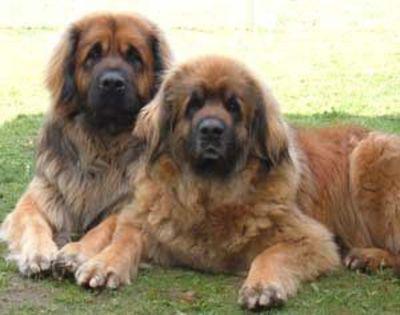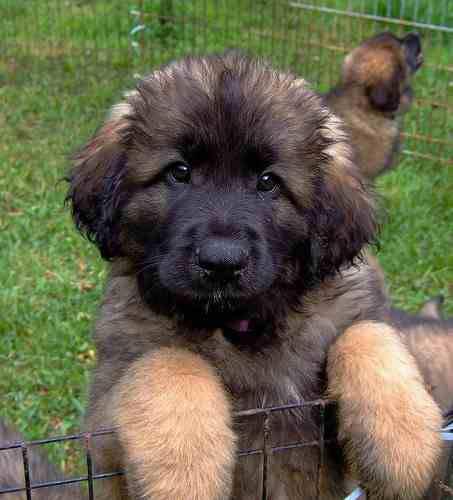The first image is the image on the left, the second image is the image on the right. Given the left and right images, does the statement "The left image includes a human interacting with a large dog." hold true? Answer yes or no. No. The first image is the image on the left, the second image is the image on the right. Evaluate the accuracy of this statement regarding the images: "In one image, a kneeling woman's head is nearly even with that of the large dog she poses next to.". Is it true? Answer yes or no. No. 